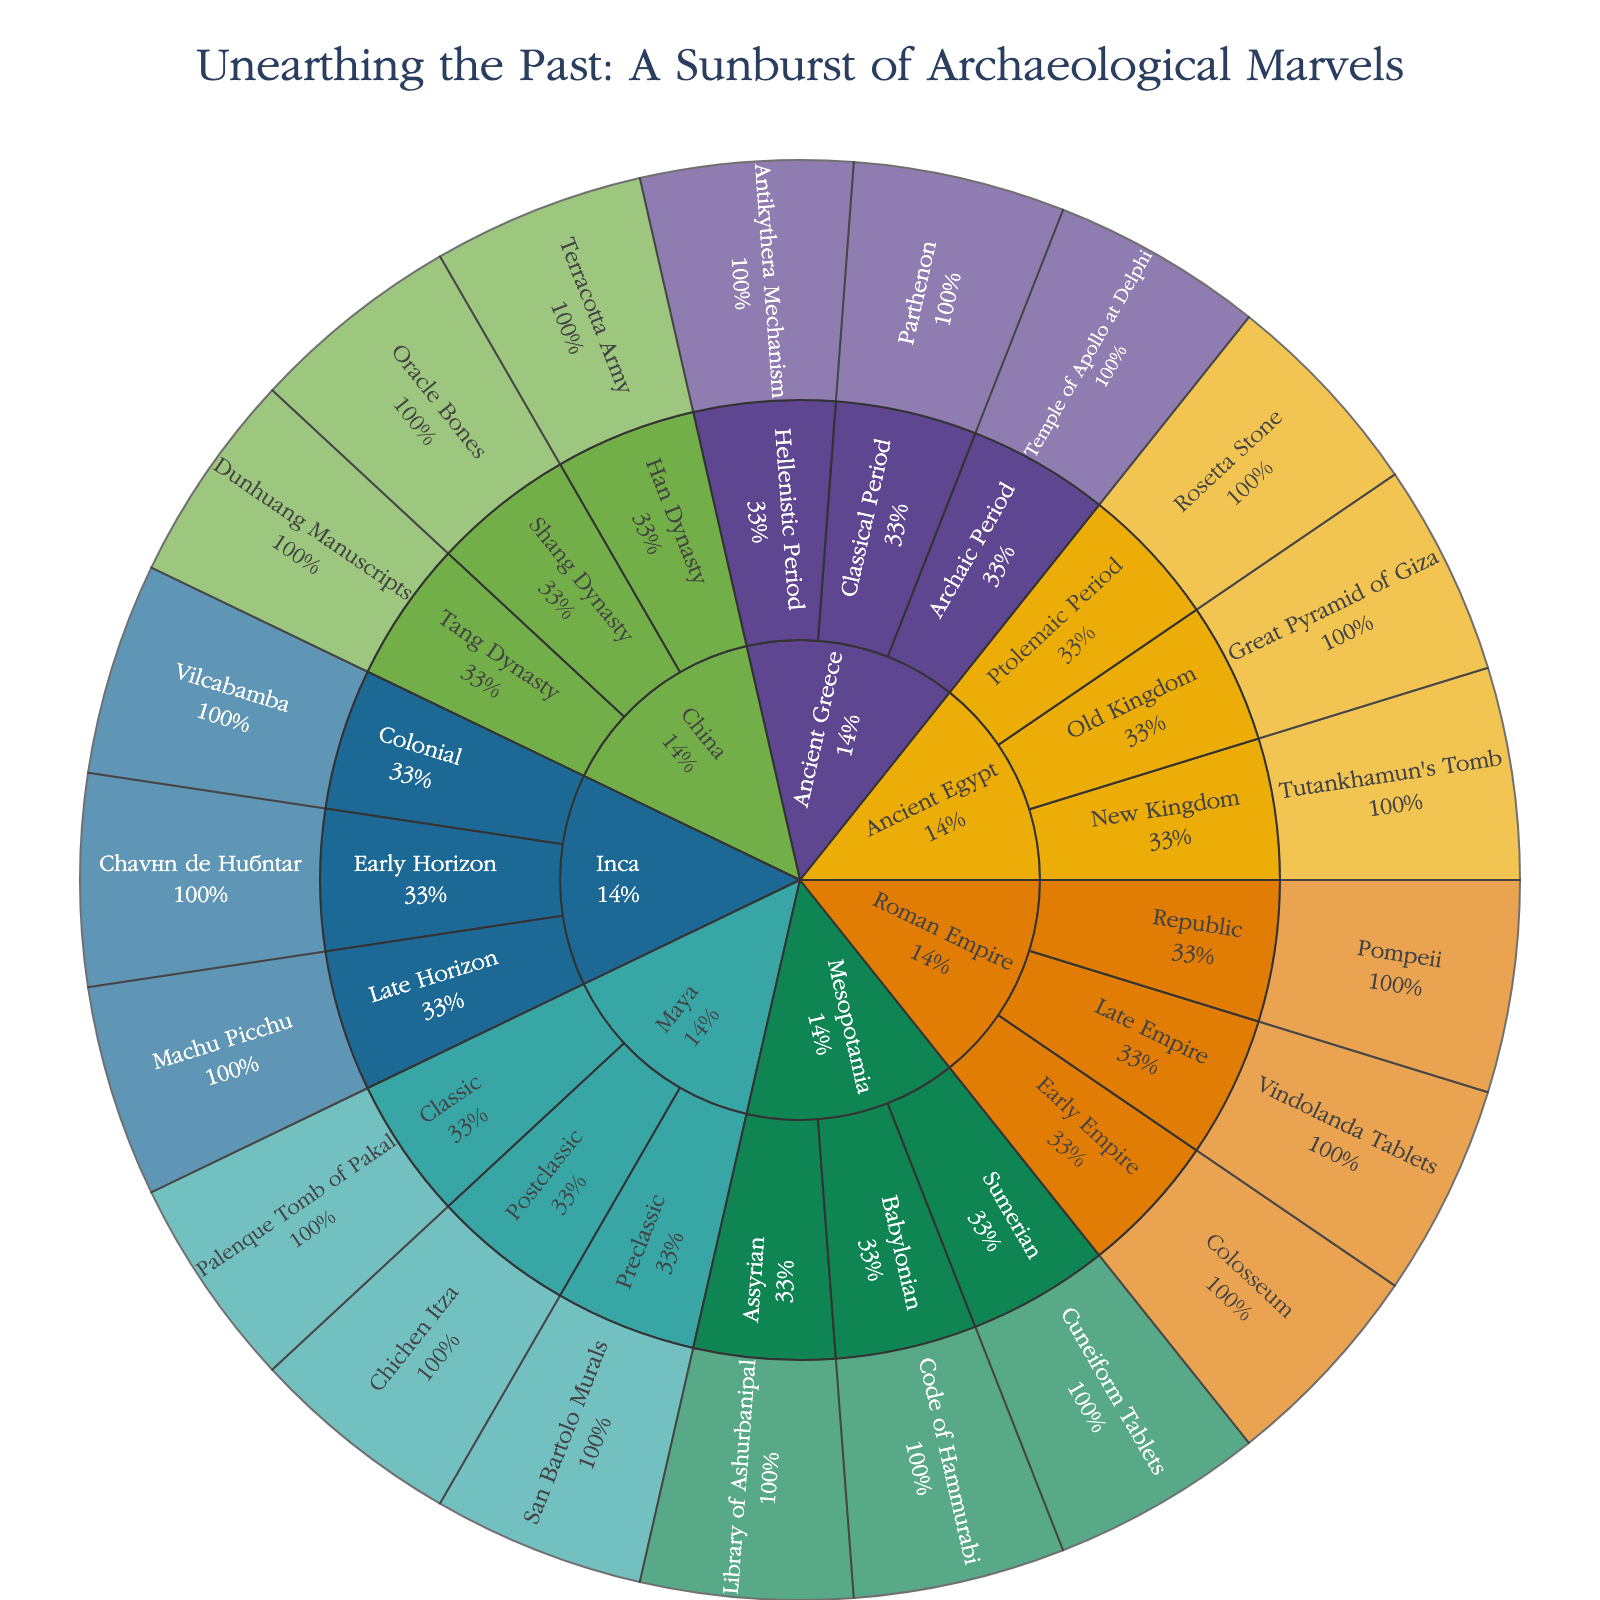what is the title of the plot? The title is usually found at the top of the visual representation. In this case, it is "Unearthing the Past: A Sunburst of Archaeological Marvels".
Answer: Unearthing the Past: A Sunburst of Archaeological Marvels How many discoveries from Mesopotamia are represented in the figure? To answer this, locate the segment for Mesopotamia and count the individual discoveries branching from it. There are three discoveries listed: Cuneiform Tablets, Code of Hammurabi, and Library of Ashurbanipal.
Answer: Three Which civilization has the fewest eras represented? Compare the segments for each civilization to see how many eras each one has. China has three different eras represented: Shang Dynasty, Han Dynasty, and Tang Dynasty. Many other civilizations, such as Ancient Egypt and the Roman Empire, also have three eras, so tie-breaking context may clarify further.
Answer: Ancient Greece Compare the Old Kingdom of Ancient Egypt to the Early Empire of the Roman Empire. What's a key feature of discoveries in each era? Follow the branches to find the discoveries. For the Old Kingdom of Ancient Egypt, the Great Pyramid of Giza is highlighted, noted for monumental architecture. For the Early Empire of the Roman Empire, the Colosseum is significant as a monumental amphitheater.
Answer: Monumental architecture vs. monumental amphitheater Which discovery is linked to early writing systems? Look for segments mentioning writing; discover Cuneiform Tablets in Mesopotamia (Sumerian) and Oracle Bones in China (Shang Dynasty), both denoted as key to early writing systems.
Answer: Cuneiform Tablets and Oracle Bones Describe the significance of the Vindolanda Tablets according to the figure. Identify the segment for Vindolanda Tablets under the Roman Empire (Late Empire). The hover data reveals they provide insights into Roman Britain.
Answer: Insights into Roman Britain How does the number of New Kingdom discoveries from Ancient Egypt compare to those from the Hellenistic Period of Ancient Greece? Count each era's discoveries. The New Kingdom of Ancient Egypt has one discovery (Tutankhamun's Tomb), while the Hellenistic Period of Ancient Greece also has one (Antikythera Mechanism).
Answer: Equal What percentage of the discoveries within the Maya civilization are from the Classic period? Determine total Maya discoveries: Preclassic (San Bartolo Murals), Classic (Palenque Tomb of Pakal), Postclassic (Chichen Itza) - a total of three. Only one is from the Classic period, therefore the percentage is (1/3)*100.
Answer: 33% Name the most recent era listed within the Inca discoveries and its associated find. Look at the most inward segments within the Inca branch; the most recent era according to the provided list is "Colonial" with the discovery being "Vilcabamba".
Answer: Colonial, Vilcabamba Out of the listed discoveries from China, which one dates back to the Shang Dynasty? Locate the segment for Shang Dynasty under China, revealing the discovery of Oracle Bones, significant for early Chinese writing.
Answer: Oracle Bones 